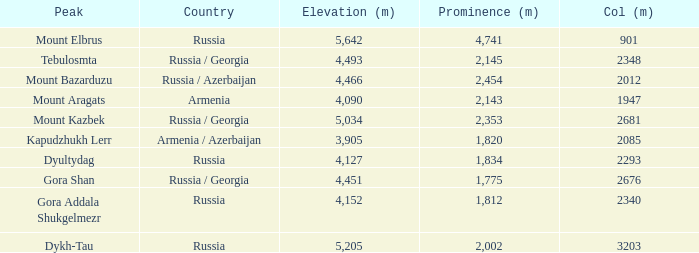What is the Col (m) of Peak Mount Aragats with an Elevation (m) larger than 3,905 and Prominence smaller than 2,143? None. Give me the full table as a dictionary. {'header': ['Peak', 'Country', 'Elevation (m)', 'Prominence (m)', 'Col (m)'], 'rows': [['Mount Elbrus', 'Russia', '5,642', '4,741', '901'], ['Tebulosmta', 'Russia / Georgia', '4,493', '2,145', '2348'], ['Mount Bazarduzu', 'Russia / Azerbaijan', '4,466', '2,454', '2012'], ['Mount Aragats', 'Armenia', '4,090', '2,143', '1947'], ['Mount Kazbek', 'Russia / Georgia', '5,034', '2,353', '2681'], ['Kapudzhukh Lerr', 'Armenia / Azerbaijan', '3,905', '1,820', '2085'], ['Dyultydag', 'Russia', '4,127', '1,834', '2293'], ['Gora Shan', 'Russia / Georgia', '4,451', '1,775', '2676'], ['Gora Addala Shukgelmezr', 'Russia', '4,152', '1,812', '2340'], ['Dykh-Tau', 'Russia', '5,205', '2,002', '3203']]} 